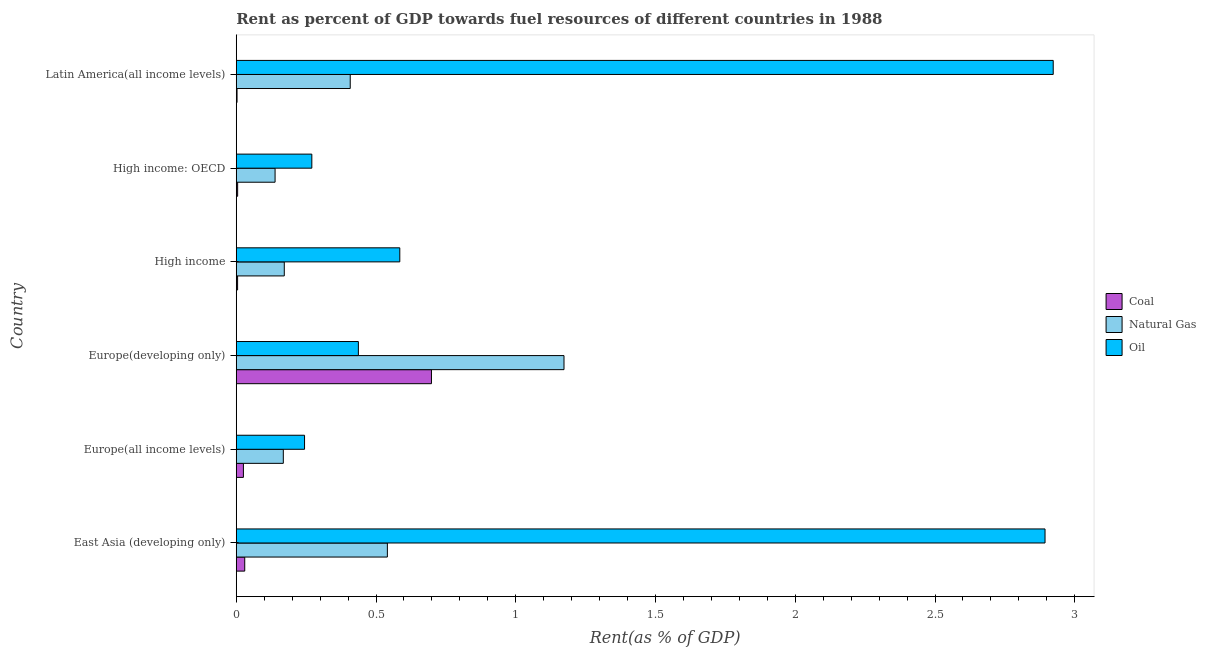How many different coloured bars are there?
Ensure brevity in your answer.  3. How many groups of bars are there?
Provide a succinct answer. 6. Are the number of bars per tick equal to the number of legend labels?
Give a very brief answer. Yes. How many bars are there on the 4th tick from the bottom?
Keep it short and to the point. 3. What is the label of the 3rd group of bars from the top?
Your answer should be very brief. High income. In how many cases, is the number of bars for a given country not equal to the number of legend labels?
Provide a succinct answer. 0. What is the rent towards oil in High income?
Offer a very short reply. 0.59. Across all countries, what is the maximum rent towards natural gas?
Your response must be concise. 1.17. Across all countries, what is the minimum rent towards oil?
Your answer should be compact. 0.24. In which country was the rent towards natural gas maximum?
Provide a short and direct response. Europe(developing only). In which country was the rent towards coal minimum?
Your answer should be very brief. Latin America(all income levels). What is the total rent towards natural gas in the graph?
Make the answer very short. 2.6. What is the difference between the rent towards natural gas in East Asia (developing only) and that in Europe(developing only)?
Offer a terse response. -0.63. What is the difference between the rent towards coal in Europe(developing only) and the rent towards oil in High income: OECD?
Your answer should be very brief. 0.43. What is the average rent towards coal per country?
Provide a short and direct response. 0.13. What is the difference between the rent towards oil and rent towards coal in High income: OECD?
Keep it short and to the point. 0.27. In how many countries, is the rent towards natural gas greater than 0.2 %?
Ensure brevity in your answer.  3. What is the ratio of the rent towards oil in High income: OECD to that in Latin America(all income levels)?
Offer a terse response. 0.09. Is the difference between the rent towards coal in East Asia (developing only) and Europe(all income levels) greater than the difference between the rent towards oil in East Asia (developing only) and Europe(all income levels)?
Offer a very short reply. No. What is the difference between the highest and the second highest rent towards natural gas?
Your response must be concise. 0.63. What is the difference between the highest and the lowest rent towards natural gas?
Give a very brief answer. 1.03. Is the sum of the rent towards oil in Europe(all income levels) and High income: OECD greater than the maximum rent towards coal across all countries?
Keep it short and to the point. No. What does the 1st bar from the top in Europe(all income levels) represents?
Keep it short and to the point. Oil. What does the 2nd bar from the bottom in High income: OECD represents?
Make the answer very short. Natural Gas. How many bars are there?
Make the answer very short. 18. Does the graph contain grids?
Your answer should be compact. No. Where does the legend appear in the graph?
Offer a terse response. Center right. What is the title of the graph?
Give a very brief answer. Rent as percent of GDP towards fuel resources of different countries in 1988. Does "Primary" appear as one of the legend labels in the graph?
Offer a very short reply. No. What is the label or title of the X-axis?
Your response must be concise. Rent(as % of GDP). What is the Rent(as % of GDP) of Coal in East Asia (developing only)?
Offer a terse response. 0.03. What is the Rent(as % of GDP) of Natural Gas in East Asia (developing only)?
Give a very brief answer. 0.54. What is the Rent(as % of GDP) of Oil in East Asia (developing only)?
Your answer should be compact. 2.89. What is the Rent(as % of GDP) of Coal in Europe(all income levels)?
Your answer should be compact. 0.03. What is the Rent(as % of GDP) in Natural Gas in Europe(all income levels)?
Make the answer very short. 0.17. What is the Rent(as % of GDP) in Oil in Europe(all income levels)?
Provide a succinct answer. 0.24. What is the Rent(as % of GDP) of Coal in Europe(developing only)?
Provide a short and direct response. 0.7. What is the Rent(as % of GDP) in Natural Gas in Europe(developing only)?
Provide a succinct answer. 1.17. What is the Rent(as % of GDP) in Oil in Europe(developing only)?
Ensure brevity in your answer.  0.44. What is the Rent(as % of GDP) of Coal in High income?
Keep it short and to the point. 0. What is the Rent(as % of GDP) in Natural Gas in High income?
Make the answer very short. 0.17. What is the Rent(as % of GDP) of Oil in High income?
Your response must be concise. 0.59. What is the Rent(as % of GDP) of Coal in High income: OECD?
Your response must be concise. 0. What is the Rent(as % of GDP) in Natural Gas in High income: OECD?
Offer a very short reply. 0.14. What is the Rent(as % of GDP) in Oil in High income: OECD?
Provide a succinct answer. 0.27. What is the Rent(as % of GDP) in Coal in Latin America(all income levels)?
Provide a short and direct response. 0. What is the Rent(as % of GDP) of Natural Gas in Latin America(all income levels)?
Keep it short and to the point. 0.41. What is the Rent(as % of GDP) of Oil in Latin America(all income levels)?
Keep it short and to the point. 2.92. Across all countries, what is the maximum Rent(as % of GDP) of Coal?
Offer a terse response. 0.7. Across all countries, what is the maximum Rent(as % of GDP) of Natural Gas?
Make the answer very short. 1.17. Across all countries, what is the maximum Rent(as % of GDP) of Oil?
Your answer should be compact. 2.92. Across all countries, what is the minimum Rent(as % of GDP) of Coal?
Provide a short and direct response. 0. Across all countries, what is the minimum Rent(as % of GDP) of Natural Gas?
Your answer should be very brief. 0.14. Across all countries, what is the minimum Rent(as % of GDP) of Oil?
Your answer should be very brief. 0.24. What is the total Rent(as % of GDP) in Coal in the graph?
Provide a succinct answer. 0.77. What is the total Rent(as % of GDP) in Natural Gas in the graph?
Give a very brief answer. 2.6. What is the total Rent(as % of GDP) of Oil in the graph?
Offer a terse response. 7.35. What is the difference between the Rent(as % of GDP) in Coal in East Asia (developing only) and that in Europe(all income levels)?
Provide a succinct answer. 0. What is the difference between the Rent(as % of GDP) of Natural Gas in East Asia (developing only) and that in Europe(all income levels)?
Ensure brevity in your answer.  0.37. What is the difference between the Rent(as % of GDP) of Oil in East Asia (developing only) and that in Europe(all income levels)?
Your answer should be very brief. 2.65. What is the difference between the Rent(as % of GDP) of Coal in East Asia (developing only) and that in Europe(developing only)?
Keep it short and to the point. -0.67. What is the difference between the Rent(as % of GDP) in Natural Gas in East Asia (developing only) and that in Europe(developing only)?
Your response must be concise. -0.63. What is the difference between the Rent(as % of GDP) in Oil in East Asia (developing only) and that in Europe(developing only)?
Provide a succinct answer. 2.46. What is the difference between the Rent(as % of GDP) in Coal in East Asia (developing only) and that in High income?
Offer a very short reply. 0.03. What is the difference between the Rent(as % of GDP) of Natural Gas in East Asia (developing only) and that in High income?
Provide a succinct answer. 0.37. What is the difference between the Rent(as % of GDP) in Oil in East Asia (developing only) and that in High income?
Provide a succinct answer. 2.31. What is the difference between the Rent(as % of GDP) in Coal in East Asia (developing only) and that in High income: OECD?
Provide a succinct answer. 0.03. What is the difference between the Rent(as % of GDP) of Natural Gas in East Asia (developing only) and that in High income: OECD?
Your response must be concise. 0.4. What is the difference between the Rent(as % of GDP) of Oil in East Asia (developing only) and that in High income: OECD?
Your response must be concise. 2.62. What is the difference between the Rent(as % of GDP) of Coal in East Asia (developing only) and that in Latin America(all income levels)?
Provide a short and direct response. 0.03. What is the difference between the Rent(as % of GDP) of Natural Gas in East Asia (developing only) and that in Latin America(all income levels)?
Make the answer very short. 0.13. What is the difference between the Rent(as % of GDP) in Oil in East Asia (developing only) and that in Latin America(all income levels)?
Ensure brevity in your answer.  -0.03. What is the difference between the Rent(as % of GDP) in Coal in Europe(all income levels) and that in Europe(developing only)?
Make the answer very short. -0.67. What is the difference between the Rent(as % of GDP) in Natural Gas in Europe(all income levels) and that in Europe(developing only)?
Your answer should be very brief. -1. What is the difference between the Rent(as % of GDP) of Oil in Europe(all income levels) and that in Europe(developing only)?
Give a very brief answer. -0.19. What is the difference between the Rent(as % of GDP) of Coal in Europe(all income levels) and that in High income?
Your answer should be compact. 0.02. What is the difference between the Rent(as % of GDP) of Natural Gas in Europe(all income levels) and that in High income?
Make the answer very short. -0. What is the difference between the Rent(as % of GDP) of Oil in Europe(all income levels) and that in High income?
Offer a terse response. -0.34. What is the difference between the Rent(as % of GDP) in Coal in Europe(all income levels) and that in High income: OECD?
Provide a succinct answer. 0.02. What is the difference between the Rent(as % of GDP) in Natural Gas in Europe(all income levels) and that in High income: OECD?
Provide a succinct answer. 0.03. What is the difference between the Rent(as % of GDP) of Oil in Europe(all income levels) and that in High income: OECD?
Keep it short and to the point. -0.03. What is the difference between the Rent(as % of GDP) of Coal in Europe(all income levels) and that in Latin America(all income levels)?
Ensure brevity in your answer.  0.02. What is the difference between the Rent(as % of GDP) in Natural Gas in Europe(all income levels) and that in Latin America(all income levels)?
Provide a succinct answer. -0.24. What is the difference between the Rent(as % of GDP) in Oil in Europe(all income levels) and that in Latin America(all income levels)?
Make the answer very short. -2.68. What is the difference between the Rent(as % of GDP) of Coal in Europe(developing only) and that in High income?
Ensure brevity in your answer.  0.69. What is the difference between the Rent(as % of GDP) of Natural Gas in Europe(developing only) and that in High income?
Give a very brief answer. 1. What is the difference between the Rent(as % of GDP) of Oil in Europe(developing only) and that in High income?
Offer a terse response. -0.15. What is the difference between the Rent(as % of GDP) of Coal in Europe(developing only) and that in High income: OECD?
Your answer should be very brief. 0.69. What is the difference between the Rent(as % of GDP) in Natural Gas in Europe(developing only) and that in High income: OECD?
Provide a succinct answer. 1.03. What is the difference between the Rent(as % of GDP) in Oil in Europe(developing only) and that in High income: OECD?
Offer a terse response. 0.17. What is the difference between the Rent(as % of GDP) of Coal in Europe(developing only) and that in Latin America(all income levels)?
Provide a succinct answer. 0.7. What is the difference between the Rent(as % of GDP) in Natural Gas in Europe(developing only) and that in Latin America(all income levels)?
Make the answer very short. 0.76. What is the difference between the Rent(as % of GDP) in Oil in Europe(developing only) and that in Latin America(all income levels)?
Give a very brief answer. -2.49. What is the difference between the Rent(as % of GDP) in Coal in High income and that in High income: OECD?
Your answer should be very brief. -0. What is the difference between the Rent(as % of GDP) of Natural Gas in High income and that in High income: OECD?
Offer a terse response. 0.03. What is the difference between the Rent(as % of GDP) of Oil in High income and that in High income: OECD?
Give a very brief answer. 0.31. What is the difference between the Rent(as % of GDP) in Coal in High income and that in Latin America(all income levels)?
Make the answer very short. 0. What is the difference between the Rent(as % of GDP) of Natural Gas in High income and that in Latin America(all income levels)?
Give a very brief answer. -0.24. What is the difference between the Rent(as % of GDP) of Oil in High income and that in Latin America(all income levels)?
Give a very brief answer. -2.34. What is the difference between the Rent(as % of GDP) of Coal in High income: OECD and that in Latin America(all income levels)?
Your response must be concise. 0. What is the difference between the Rent(as % of GDP) of Natural Gas in High income: OECD and that in Latin America(all income levels)?
Make the answer very short. -0.27. What is the difference between the Rent(as % of GDP) in Oil in High income: OECD and that in Latin America(all income levels)?
Offer a very short reply. -2.65. What is the difference between the Rent(as % of GDP) of Coal in East Asia (developing only) and the Rent(as % of GDP) of Natural Gas in Europe(all income levels)?
Give a very brief answer. -0.14. What is the difference between the Rent(as % of GDP) of Coal in East Asia (developing only) and the Rent(as % of GDP) of Oil in Europe(all income levels)?
Provide a short and direct response. -0.21. What is the difference between the Rent(as % of GDP) of Natural Gas in East Asia (developing only) and the Rent(as % of GDP) of Oil in Europe(all income levels)?
Offer a terse response. 0.3. What is the difference between the Rent(as % of GDP) of Coal in East Asia (developing only) and the Rent(as % of GDP) of Natural Gas in Europe(developing only)?
Offer a very short reply. -1.14. What is the difference between the Rent(as % of GDP) of Coal in East Asia (developing only) and the Rent(as % of GDP) of Oil in Europe(developing only)?
Provide a short and direct response. -0.41. What is the difference between the Rent(as % of GDP) in Natural Gas in East Asia (developing only) and the Rent(as % of GDP) in Oil in Europe(developing only)?
Make the answer very short. 0.1. What is the difference between the Rent(as % of GDP) in Coal in East Asia (developing only) and the Rent(as % of GDP) in Natural Gas in High income?
Ensure brevity in your answer.  -0.14. What is the difference between the Rent(as % of GDP) in Coal in East Asia (developing only) and the Rent(as % of GDP) in Oil in High income?
Your answer should be compact. -0.55. What is the difference between the Rent(as % of GDP) of Natural Gas in East Asia (developing only) and the Rent(as % of GDP) of Oil in High income?
Provide a succinct answer. -0.04. What is the difference between the Rent(as % of GDP) in Coal in East Asia (developing only) and the Rent(as % of GDP) in Natural Gas in High income: OECD?
Keep it short and to the point. -0.11. What is the difference between the Rent(as % of GDP) of Coal in East Asia (developing only) and the Rent(as % of GDP) of Oil in High income: OECD?
Make the answer very short. -0.24. What is the difference between the Rent(as % of GDP) in Natural Gas in East Asia (developing only) and the Rent(as % of GDP) in Oil in High income: OECD?
Offer a very short reply. 0.27. What is the difference between the Rent(as % of GDP) in Coal in East Asia (developing only) and the Rent(as % of GDP) in Natural Gas in Latin America(all income levels)?
Your response must be concise. -0.38. What is the difference between the Rent(as % of GDP) in Coal in East Asia (developing only) and the Rent(as % of GDP) in Oil in Latin America(all income levels)?
Give a very brief answer. -2.89. What is the difference between the Rent(as % of GDP) in Natural Gas in East Asia (developing only) and the Rent(as % of GDP) in Oil in Latin America(all income levels)?
Your response must be concise. -2.38. What is the difference between the Rent(as % of GDP) of Coal in Europe(all income levels) and the Rent(as % of GDP) of Natural Gas in Europe(developing only)?
Make the answer very short. -1.15. What is the difference between the Rent(as % of GDP) in Coal in Europe(all income levels) and the Rent(as % of GDP) in Oil in Europe(developing only)?
Keep it short and to the point. -0.41. What is the difference between the Rent(as % of GDP) of Natural Gas in Europe(all income levels) and the Rent(as % of GDP) of Oil in Europe(developing only)?
Ensure brevity in your answer.  -0.27. What is the difference between the Rent(as % of GDP) of Coal in Europe(all income levels) and the Rent(as % of GDP) of Natural Gas in High income?
Give a very brief answer. -0.15. What is the difference between the Rent(as % of GDP) of Coal in Europe(all income levels) and the Rent(as % of GDP) of Oil in High income?
Provide a short and direct response. -0.56. What is the difference between the Rent(as % of GDP) of Natural Gas in Europe(all income levels) and the Rent(as % of GDP) of Oil in High income?
Provide a short and direct response. -0.42. What is the difference between the Rent(as % of GDP) of Coal in Europe(all income levels) and the Rent(as % of GDP) of Natural Gas in High income: OECD?
Give a very brief answer. -0.11. What is the difference between the Rent(as % of GDP) of Coal in Europe(all income levels) and the Rent(as % of GDP) of Oil in High income: OECD?
Keep it short and to the point. -0.24. What is the difference between the Rent(as % of GDP) in Natural Gas in Europe(all income levels) and the Rent(as % of GDP) in Oil in High income: OECD?
Your answer should be compact. -0.1. What is the difference between the Rent(as % of GDP) in Coal in Europe(all income levels) and the Rent(as % of GDP) in Natural Gas in Latin America(all income levels)?
Provide a succinct answer. -0.38. What is the difference between the Rent(as % of GDP) in Coal in Europe(all income levels) and the Rent(as % of GDP) in Oil in Latin America(all income levels)?
Ensure brevity in your answer.  -2.9. What is the difference between the Rent(as % of GDP) in Natural Gas in Europe(all income levels) and the Rent(as % of GDP) in Oil in Latin America(all income levels)?
Provide a short and direct response. -2.75. What is the difference between the Rent(as % of GDP) in Coal in Europe(developing only) and the Rent(as % of GDP) in Natural Gas in High income?
Ensure brevity in your answer.  0.53. What is the difference between the Rent(as % of GDP) in Coal in Europe(developing only) and the Rent(as % of GDP) in Oil in High income?
Your response must be concise. 0.11. What is the difference between the Rent(as % of GDP) of Natural Gas in Europe(developing only) and the Rent(as % of GDP) of Oil in High income?
Provide a succinct answer. 0.59. What is the difference between the Rent(as % of GDP) of Coal in Europe(developing only) and the Rent(as % of GDP) of Natural Gas in High income: OECD?
Your answer should be compact. 0.56. What is the difference between the Rent(as % of GDP) of Coal in Europe(developing only) and the Rent(as % of GDP) of Oil in High income: OECD?
Make the answer very short. 0.43. What is the difference between the Rent(as % of GDP) of Natural Gas in Europe(developing only) and the Rent(as % of GDP) of Oil in High income: OECD?
Your answer should be compact. 0.9. What is the difference between the Rent(as % of GDP) of Coal in Europe(developing only) and the Rent(as % of GDP) of Natural Gas in Latin America(all income levels)?
Make the answer very short. 0.29. What is the difference between the Rent(as % of GDP) of Coal in Europe(developing only) and the Rent(as % of GDP) of Oil in Latin America(all income levels)?
Keep it short and to the point. -2.22. What is the difference between the Rent(as % of GDP) of Natural Gas in Europe(developing only) and the Rent(as % of GDP) of Oil in Latin America(all income levels)?
Give a very brief answer. -1.75. What is the difference between the Rent(as % of GDP) in Coal in High income and the Rent(as % of GDP) in Natural Gas in High income: OECD?
Make the answer very short. -0.13. What is the difference between the Rent(as % of GDP) in Coal in High income and the Rent(as % of GDP) in Oil in High income: OECD?
Give a very brief answer. -0.27. What is the difference between the Rent(as % of GDP) in Natural Gas in High income and the Rent(as % of GDP) in Oil in High income: OECD?
Provide a succinct answer. -0.1. What is the difference between the Rent(as % of GDP) of Coal in High income and the Rent(as % of GDP) of Natural Gas in Latin America(all income levels)?
Give a very brief answer. -0.4. What is the difference between the Rent(as % of GDP) of Coal in High income and the Rent(as % of GDP) of Oil in Latin America(all income levels)?
Keep it short and to the point. -2.92. What is the difference between the Rent(as % of GDP) in Natural Gas in High income and the Rent(as % of GDP) in Oil in Latin America(all income levels)?
Your answer should be compact. -2.75. What is the difference between the Rent(as % of GDP) in Coal in High income: OECD and the Rent(as % of GDP) in Natural Gas in Latin America(all income levels)?
Give a very brief answer. -0.4. What is the difference between the Rent(as % of GDP) in Coal in High income: OECD and the Rent(as % of GDP) in Oil in Latin America(all income levels)?
Provide a succinct answer. -2.92. What is the difference between the Rent(as % of GDP) of Natural Gas in High income: OECD and the Rent(as % of GDP) of Oil in Latin America(all income levels)?
Your answer should be compact. -2.78. What is the average Rent(as % of GDP) of Coal per country?
Provide a succinct answer. 0.13. What is the average Rent(as % of GDP) of Natural Gas per country?
Offer a very short reply. 0.43. What is the average Rent(as % of GDP) in Oil per country?
Ensure brevity in your answer.  1.23. What is the difference between the Rent(as % of GDP) of Coal and Rent(as % of GDP) of Natural Gas in East Asia (developing only)?
Provide a succinct answer. -0.51. What is the difference between the Rent(as % of GDP) of Coal and Rent(as % of GDP) of Oil in East Asia (developing only)?
Keep it short and to the point. -2.86. What is the difference between the Rent(as % of GDP) in Natural Gas and Rent(as % of GDP) in Oil in East Asia (developing only)?
Keep it short and to the point. -2.35. What is the difference between the Rent(as % of GDP) of Coal and Rent(as % of GDP) of Natural Gas in Europe(all income levels)?
Give a very brief answer. -0.14. What is the difference between the Rent(as % of GDP) in Coal and Rent(as % of GDP) in Oil in Europe(all income levels)?
Ensure brevity in your answer.  -0.22. What is the difference between the Rent(as % of GDP) in Natural Gas and Rent(as % of GDP) in Oil in Europe(all income levels)?
Give a very brief answer. -0.08. What is the difference between the Rent(as % of GDP) in Coal and Rent(as % of GDP) in Natural Gas in Europe(developing only)?
Give a very brief answer. -0.47. What is the difference between the Rent(as % of GDP) in Coal and Rent(as % of GDP) in Oil in Europe(developing only)?
Your response must be concise. 0.26. What is the difference between the Rent(as % of GDP) in Natural Gas and Rent(as % of GDP) in Oil in Europe(developing only)?
Your answer should be very brief. 0.74. What is the difference between the Rent(as % of GDP) in Coal and Rent(as % of GDP) in Natural Gas in High income?
Your response must be concise. -0.17. What is the difference between the Rent(as % of GDP) of Coal and Rent(as % of GDP) of Oil in High income?
Your answer should be very brief. -0.58. What is the difference between the Rent(as % of GDP) in Natural Gas and Rent(as % of GDP) in Oil in High income?
Give a very brief answer. -0.41. What is the difference between the Rent(as % of GDP) in Coal and Rent(as % of GDP) in Natural Gas in High income: OECD?
Your answer should be very brief. -0.13. What is the difference between the Rent(as % of GDP) of Coal and Rent(as % of GDP) of Oil in High income: OECD?
Keep it short and to the point. -0.27. What is the difference between the Rent(as % of GDP) of Natural Gas and Rent(as % of GDP) of Oil in High income: OECD?
Offer a terse response. -0.13. What is the difference between the Rent(as % of GDP) in Coal and Rent(as % of GDP) in Natural Gas in Latin America(all income levels)?
Your response must be concise. -0.41. What is the difference between the Rent(as % of GDP) in Coal and Rent(as % of GDP) in Oil in Latin America(all income levels)?
Offer a very short reply. -2.92. What is the difference between the Rent(as % of GDP) of Natural Gas and Rent(as % of GDP) of Oil in Latin America(all income levels)?
Make the answer very short. -2.52. What is the ratio of the Rent(as % of GDP) of Coal in East Asia (developing only) to that in Europe(all income levels)?
Provide a short and direct response. 1.19. What is the ratio of the Rent(as % of GDP) of Natural Gas in East Asia (developing only) to that in Europe(all income levels)?
Give a very brief answer. 3.21. What is the ratio of the Rent(as % of GDP) of Oil in East Asia (developing only) to that in Europe(all income levels)?
Make the answer very short. 11.84. What is the ratio of the Rent(as % of GDP) of Coal in East Asia (developing only) to that in Europe(developing only)?
Keep it short and to the point. 0.04. What is the ratio of the Rent(as % of GDP) in Natural Gas in East Asia (developing only) to that in Europe(developing only)?
Provide a short and direct response. 0.46. What is the ratio of the Rent(as % of GDP) of Oil in East Asia (developing only) to that in Europe(developing only)?
Make the answer very short. 6.62. What is the ratio of the Rent(as % of GDP) in Coal in East Asia (developing only) to that in High income?
Offer a terse response. 6.36. What is the ratio of the Rent(as % of GDP) in Natural Gas in East Asia (developing only) to that in High income?
Your answer should be very brief. 3.15. What is the ratio of the Rent(as % of GDP) in Oil in East Asia (developing only) to that in High income?
Provide a succinct answer. 4.95. What is the ratio of the Rent(as % of GDP) of Coal in East Asia (developing only) to that in High income: OECD?
Your response must be concise. 6.11. What is the ratio of the Rent(as % of GDP) of Natural Gas in East Asia (developing only) to that in High income: OECD?
Your answer should be very brief. 3.89. What is the ratio of the Rent(as % of GDP) in Oil in East Asia (developing only) to that in High income: OECD?
Provide a succinct answer. 10.7. What is the ratio of the Rent(as % of GDP) of Coal in East Asia (developing only) to that in Latin America(all income levels)?
Make the answer very short. 10.64. What is the ratio of the Rent(as % of GDP) of Natural Gas in East Asia (developing only) to that in Latin America(all income levels)?
Offer a very short reply. 1.33. What is the ratio of the Rent(as % of GDP) in Oil in East Asia (developing only) to that in Latin America(all income levels)?
Ensure brevity in your answer.  0.99. What is the ratio of the Rent(as % of GDP) in Coal in Europe(all income levels) to that in Europe(developing only)?
Provide a succinct answer. 0.04. What is the ratio of the Rent(as % of GDP) of Natural Gas in Europe(all income levels) to that in Europe(developing only)?
Provide a succinct answer. 0.14. What is the ratio of the Rent(as % of GDP) in Oil in Europe(all income levels) to that in Europe(developing only)?
Offer a very short reply. 0.56. What is the ratio of the Rent(as % of GDP) in Coal in Europe(all income levels) to that in High income?
Give a very brief answer. 5.36. What is the ratio of the Rent(as % of GDP) of Natural Gas in Europe(all income levels) to that in High income?
Offer a terse response. 0.98. What is the ratio of the Rent(as % of GDP) of Oil in Europe(all income levels) to that in High income?
Your response must be concise. 0.42. What is the ratio of the Rent(as % of GDP) of Coal in Europe(all income levels) to that in High income: OECD?
Offer a very short reply. 5.15. What is the ratio of the Rent(as % of GDP) in Natural Gas in Europe(all income levels) to that in High income: OECD?
Your response must be concise. 1.21. What is the ratio of the Rent(as % of GDP) in Oil in Europe(all income levels) to that in High income: OECD?
Give a very brief answer. 0.9. What is the ratio of the Rent(as % of GDP) of Coal in Europe(all income levels) to that in Latin America(all income levels)?
Offer a very short reply. 8.97. What is the ratio of the Rent(as % of GDP) in Natural Gas in Europe(all income levels) to that in Latin America(all income levels)?
Offer a terse response. 0.41. What is the ratio of the Rent(as % of GDP) in Oil in Europe(all income levels) to that in Latin America(all income levels)?
Your response must be concise. 0.08. What is the ratio of the Rent(as % of GDP) in Coal in Europe(developing only) to that in High income?
Your answer should be compact. 146.48. What is the ratio of the Rent(as % of GDP) in Natural Gas in Europe(developing only) to that in High income?
Your answer should be very brief. 6.82. What is the ratio of the Rent(as % of GDP) of Oil in Europe(developing only) to that in High income?
Make the answer very short. 0.75. What is the ratio of the Rent(as % of GDP) of Coal in Europe(developing only) to that in High income: OECD?
Make the answer very short. 140.74. What is the ratio of the Rent(as % of GDP) of Natural Gas in Europe(developing only) to that in High income: OECD?
Provide a short and direct response. 8.44. What is the ratio of the Rent(as % of GDP) of Oil in Europe(developing only) to that in High income: OECD?
Give a very brief answer. 1.62. What is the ratio of the Rent(as % of GDP) of Coal in Europe(developing only) to that in Latin America(all income levels)?
Provide a succinct answer. 245.06. What is the ratio of the Rent(as % of GDP) in Natural Gas in Europe(developing only) to that in Latin America(all income levels)?
Your answer should be compact. 2.88. What is the ratio of the Rent(as % of GDP) of Oil in Europe(developing only) to that in Latin America(all income levels)?
Provide a succinct answer. 0.15. What is the ratio of the Rent(as % of GDP) of Coal in High income to that in High income: OECD?
Give a very brief answer. 0.96. What is the ratio of the Rent(as % of GDP) of Natural Gas in High income to that in High income: OECD?
Keep it short and to the point. 1.24. What is the ratio of the Rent(as % of GDP) of Oil in High income to that in High income: OECD?
Offer a very short reply. 2.16. What is the ratio of the Rent(as % of GDP) in Coal in High income to that in Latin America(all income levels)?
Your response must be concise. 1.67. What is the ratio of the Rent(as % of GDP) in Natural Gas in High income to that in Latin America(all income levels)?
Your answer should be very brief. 0.42. What is the ratio of the Rent(as % of GDP) in Oil in High income to that in Latin America(all income levels)?
Offer a very short reply. 0.2. What is the ratio of the Rent(as % of GDP) of Coal in High income: OECD to that in Latin America(all income levels)?
Keep it short and to the point. 1.74. What is the ratio of the Rent(as % of GDP) in Natural Gas in High income: OECD to that in Latin America(all income levels)?
Provide a short and direct response. 0.34. What is the ratio of the Rent(as % of GDP) of Oil in High income: OECD to that in Latin America(all income levels)?
Give a very brief answer. 0.09. What is the difference between the highest and the second highest Rent(as % of GDP) of Coal?
Make the answer very short. 0.67. What is the difference between the highest and the second highest Rent(as % of GDP) in Natural Gas?
Your answer should be compact. 0.63. What is the difference between the highest and the second highest Rent(as % of GDP) of Oil?
Your answer should be very brief. 0.03. What is the difference between the highest and the lowest Rent(as % of GDP) in Coal?
Provide a short and direct response. 0.7. What is the difference between the highest and the lowest Rent(as % of GDP) in Natural Gas?
Your response must be concise. 1.03. What is the difference between the highest and the lowest Rent(as % of GDP) of Oil?
Keep it short and to the point. 2.68. 